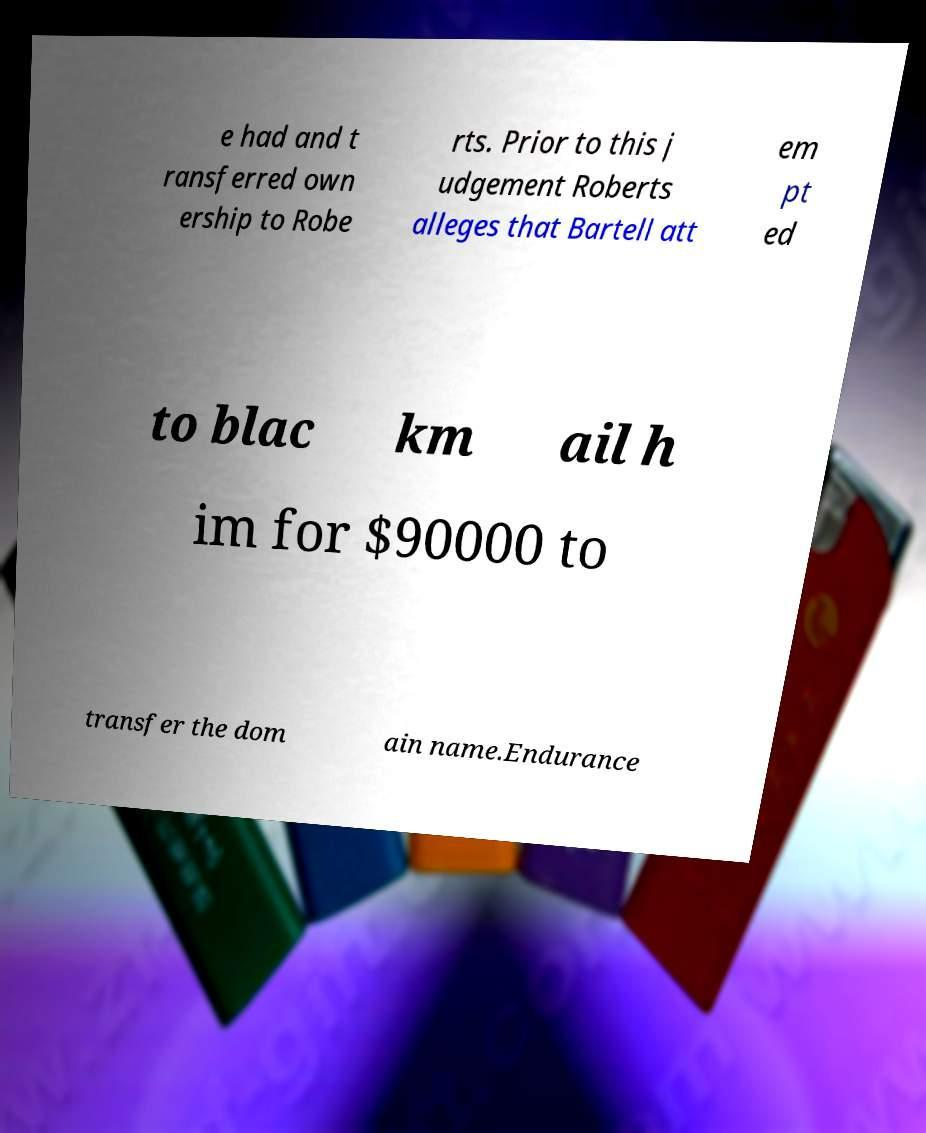There's text embedded in this image that I need extracted. Can you transcribe it verbatim? e had and t ransferred own ership to Robe rts. Prior to this j udgement Roberts alleges that Bartell att em pt ed to blac km ail h im for $90000 to transfer the dom ain name.Endurance 